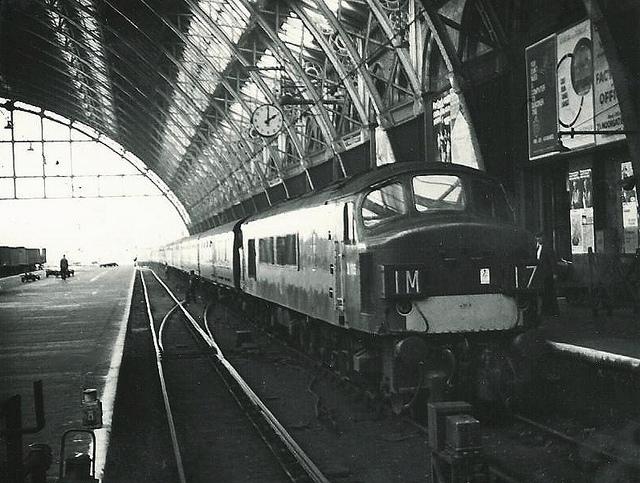What color is the photo?
Be succinct. Black and white. What are the numbers on the right side of the train?
Write a very short answer. 17. Did the train just stop?
Write a very short answer. Yes. 